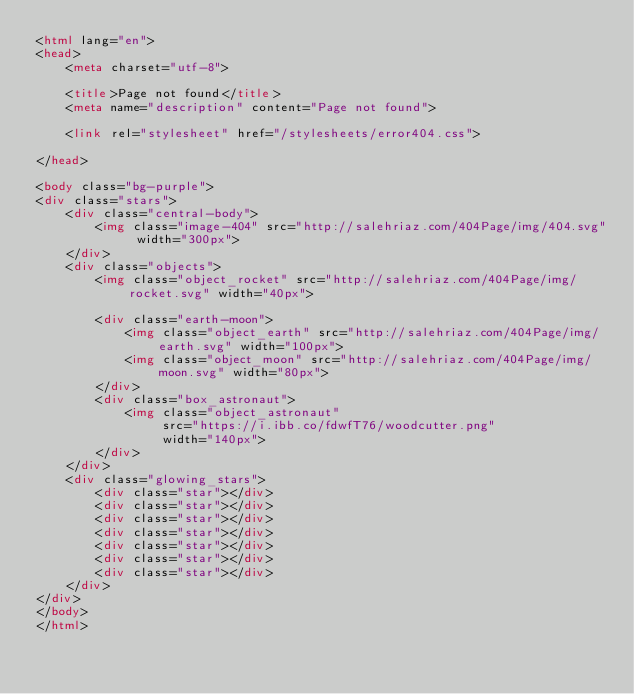<code> <loc_0><loc_0><loc_500><loc_500><_HTML_><html lang="en">
<head>
    <meta charset="utf-8">

    <title>Page not found</title>
    <meta name="description" content="Page not found">

    <link rel="stylesheet" href="/stylesheets/error404.css">

</head>

<body class="bg-purple">
<div class="stars">
    <div class="central-body">
        <img class="image-404" src="http://salehriaz.com/404Page/img/404.svg" width="300px">
    </div>
    <div class="objects">
        <img class="object_rocket" src="http://salehriaz.com/404Page/img/rocket.svg" width="40px">

        <div class="earth-moon">
            <img class="object_earth" src="http://salehriaz.com/404Page/img/earth.svg" width="100px">
            <img class="object_moon" src="http://salehriaz.com/404Page/img/moon.svg" width="80px">
        </div>
        <div class="box_astronaut">
            <img class="object_astronaut"
                 src="https://i.ibb.co/fdwfT76/woodcutter.png"
                 width="140px">
        </div>
    </div>
    <div class="glowing_stars">
        <div class="star"></div>
        <div class="star"></div>
        <div class="star"></div>
        <div class="star"></div>
        <div class="star"></div>
        <div class="star"></div>
        <div class="star"></div>
    </div>
</div>
</body>
</html>



</code> 